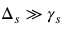<formula> <loc_0><loc_0><loc_500><loc_500>\Delta _ { s } \gg \gamma _ { s }</formula> 